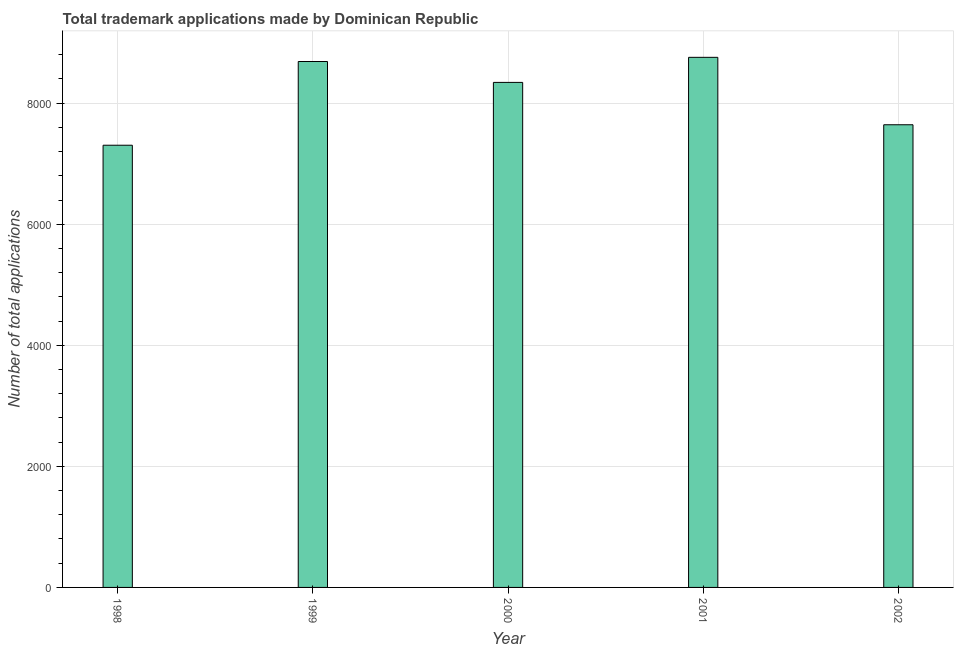Does the graph contain grids?
Your answer should be compact. Yes. What is the title of the graph?
Make the answer very short. Total trademark applications made by Dominican Republic. What is the label or title of the X-axis?
Offer a very short reply. Year. What is the label or title of the Y-axis?
Keep it short and to the point. Number of total applications. What is the number of trademark applications in 1998?
Ensure brevity in your answer.  7305. Across all years, what is the maximum number of trademark applications?
Your answer should be very brief. 8757. Across all years, what is the minimum number of trademark applications?
Make the answer very short. 7305. In which year was the number of trademark applications maximum?
Offer a terse response. 2001. In which year was the number of trademark applications minimum?
Keep it short and to the point. 1998. What is the sum of the number of trademark applications?
Provide a succinct answer. 4.07e+04. What is the difference between the number of trademark applications in 2000 and 2001?
Make the answer very short. -414. What is the average number of trademark applications per year?
Provide a short and direct response. 8147. What is the median number of trademark applications?
Offer a terse response. 8343. In how many years, is the number of trademark applications greater than 2000 ?
Offer a terse response. 5. Is the sum of the number of trademark applications in 1998 and 2001 greater than the maximum number of trademark applications across all years?
Offer a terse response. Yes. What is the difference between the highest and the lowest number of trademark applications?
Ensure brevity in your answer.  1452. In how many years, is the number of trademark applications greater than the average number of trademark applications taken over all years?
Your answer should be very brief. 3. How many bars are there?
Provide a succinct answer. 5. Are all the bars in the graph horizontal?
Keep it short and to the point. No. How many years are there in the graph?
Give a very brief answer. 5. Are the values on the major ticks of Y-axis written in scientific E-notation?
Keep it short and to the point. No. What is the Number of total applications in 1998?
Offer a terse response. 7305. What is the Number of total applications of 1999?
Ensure brevity in your answer.  8688. What is the Number of total applications of 2000?
Your answer should be compact. 8343. What is the Number of total applications in 2001?
Give a very brief answer. 8757. What is the Number of total applications in 2002?
Offer a terse response. 7643. What is the difference between the Number of total applications in 1998 and 1999?
Offer a terse response. -1383. What is the difference between the Number of total applications in 1998 and 2000?
Provide a short and direct response. -1038. What is the difference between the Number of total applications in 1998 and 2001?
Offer a terse response. -1452. What is the difference between the Number of total applications in 1998 and 2002?
Your answer should be very brief. -338. What is the difference between the Number of total applications in 1999 and 2000?
Make the answer very short. 345. What is the difference between the Number of total applications in 1999 and 2001?
Provide a succinct answer. -69. What is the difference between the Number of total applications in 1999 and 2002?
Keep it short and to the point. 1045. What is the difference between the Number of total applications in 2000 and 2001?
Offer a terse response. -414. What is the difference between the Number of total applications in 2000 and 2002?
Provide a short and direct response. 700. What is the difference between the Number of total applications in 2001 and 2002?
Ensure brevity in your answer.  1114. What is the ratio of the Number of total applications in 1998 to that in 1999?
Offer a terse response. 0.84. What is the ratio of the Number of total applications in 1998 to that in 2000?
Offer a very short reply. 0.88. What is the ratio of the Number of total applications in 1998 to that in 2001?
Offer a terse response. 0.83. What is the ratio of the Number of total applications in 1998 to that in 2002?
Give a very brief answer. 0.96. What is the ratio of the Number of total applications in 1999 to that in 2000?
Your answer should be very brief. 1.04. What is the ratio of the Number of total applications in 1999 to that in 2002?
Your answer should be compact. 1.14. What is the ratio of the Number of total applications in 2000 to that in 2001?
Provide a succinct answer. 0.95. What is the ratio of the Number of total applications in 2000 to that in 2002?
Provide a succinct answer. 1.09. What is the ratio of the Number of total applications in 2001 to that in 2002?
Your answer should be compact. 1.15. 